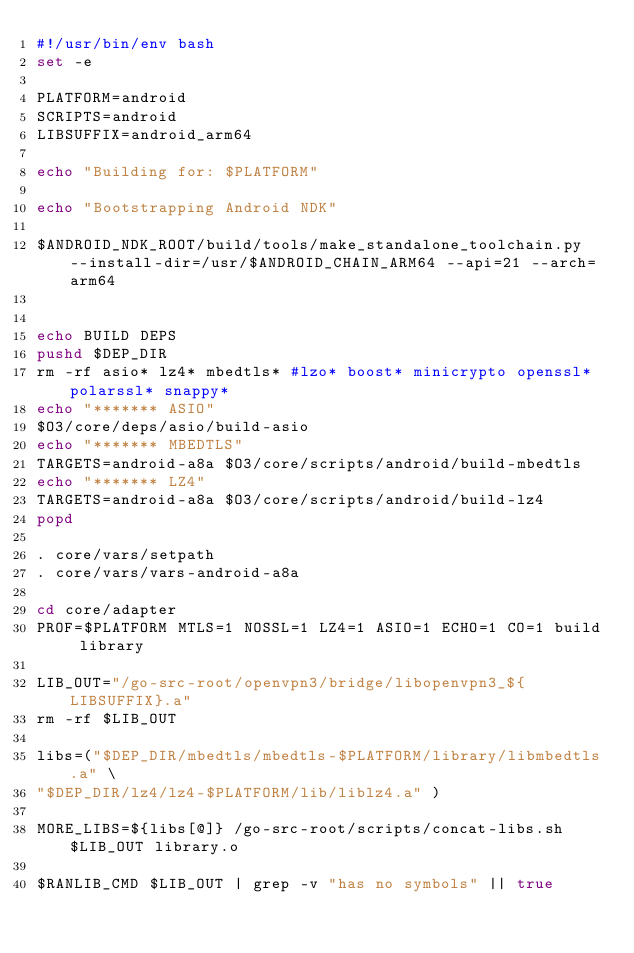Convert code to text. <code><loc_0><loc_0><loc_500><loc_500><_Bash_>#!/usr/bin/env bash
set -e

PLATFORM=android
SCRIPTS=android
LIBSUFFIX=android_arm64

echo "Building for: $PLATFORM"

echo "Bootstrapping Android NDK"

$ANDROID_NDK_ROOT/build/tools/make_standalone_toolchain.py --install-dir=/usr/$ANDROID_CHAIN_ARM64 --api=21 --arch=arm64


echo BUILD DEPS
pushd $DEP_DIR
rm -rf asio* lz4* mbedtls* #lzo* boost* minicrypto openssl* polarssl* snappy*
echo "******* ASIO"
$O3/core/deps/asio/build-asio
echo "******* MBEDTLS"
TARGETS=android-a8a $O3/core/scripts/android/build-mbedtls
echo "******* LZ4"
TARGETS=android-a8a $O3/core/scripts/android/build-lz4
popd

. core/vars/setpath
. core/vars/vars-android-a8a

cd core/adapter
PROF=$PLATFORM MTLS=1 NOSSL=1 LZ4=1 ASIO=1 ECHO=1 CO=1 build library

LIB_OUT="/go-src-root/openvpn3/bridge/libopenvpn3_${LIBSUFFIX}.a"
rm -rf $LIB_OUT

libs=("$DEP_DIR/mbedtls/mbedtls-$PLATFORM/library/libmbedtls.a" \
"$DEP_DIR/lz4/lz4-$PLATFORM/lib/liblz4.a" )

MORE_LIBS=${libs[@]} /go-src-root/scripts/concat-libs.sh $LIB_OUT library.o

$RANLIB_CMD $LIB_OUT | grep -v "has no symbols" || true
</code> 